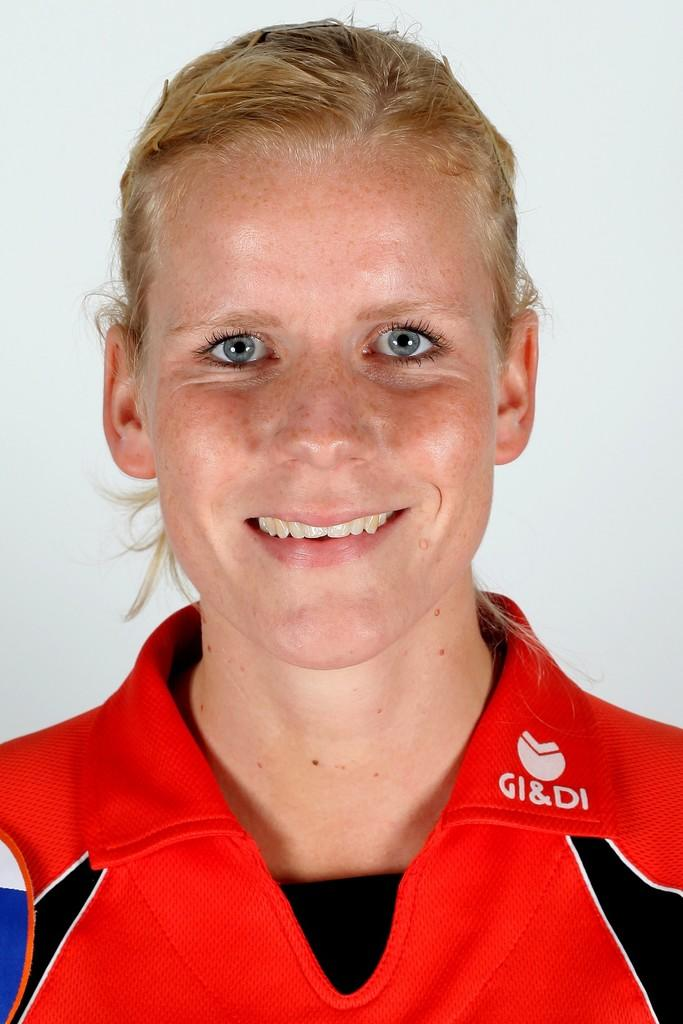Who is in the picture? There is a woman in the picture. What is the woman doing in the picture? The woman is smiling in the picture. What is the woman wearing in the picture? The woman is wearing a red jersey in the picture. What is the color of the background in the picture? The background of the image is white. What is the range of the woman's laughter in the image? The range of the woman's laughter cannot be determined from the image, as laughter is an auditory expression and not visible. 